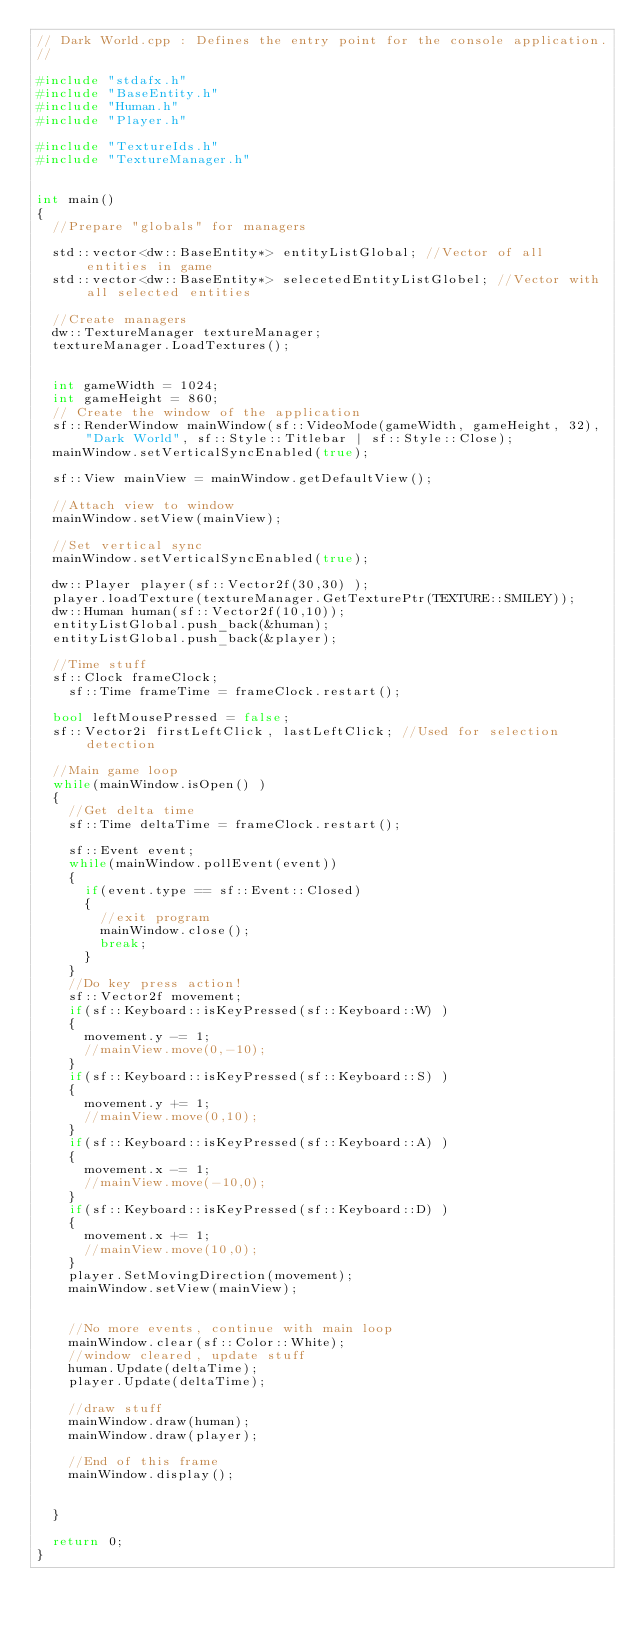Convert code to text. <code><loc_0><loc_0><loc_500><loc_500><_C++_>// Dark World.cpp : Defines the entry point for the console application.
//

#include "stdafx.h"
#include "BaseEntity.h"
#include "Human.h"
#include "Player.h"

#include "TextureIds.h"
#include "TextureManager.h"


int main()
{
  //Prepare "globals" for managers

  std::vector<dw::BaseEntity*> entityListGlobal; //Vector of all entities in game
  std::vector<dw::BaseEntity*> selecetedEntityListGlobel; //Vector with all selected entities

  //Create managers
  dw::TextureManager textureManager;
  textureManager.LoadTextures();


  int gameWidth = 1024;
  int gameHeight = 860;
  // Create the window of the application
  sf::RenderWindow mainWindow(sf::VideoMode(gameWidth, gameHeight, 32), "Dark World", sf::Style::Titlebar | sf::Style::Close);
  mainWindow.setVerticalSyncEnabled(true);

  sf::View mainView = mainWindow.getDefaultView();

  //Attach view to window
  mainWindow.setView(mainView);

  //Set vertical sync
  mainWindow.setVerticalSyncEnabled(true);

  dw::Player player(sf::Vector2f(30,30) );
  player.loadTexture(textureManager.GetTexturePtr(TEXTURE::SMILEY));
  dw::Human human(sf::Vector2f(10,10));
  entityListGlobal.push_back(&human);
  entityListGlobal.push_back(&player);

  //Time stuff
  sf::Clock frameClock;
	sf::Time frameTime = frameClock.restart();

  bool leftMousePressed = false;
  sf::Vector2i firstLeftClick, lastLeftClick; //Used for selection detection

  //Main game loop
  while(mainWindow.isOpen() )
  {
    //Get delta time
    sf::Time deltaTime = frameClock.restart();

    sf::Event event;
    while(mainWindow.pollEvent(event))
    {
      if(event.type == sf::Event::Closed)
      {
        //exit program
        mainWindow.close();
        break;
      }
    }
    //Do key press action!
    sf::Vector2f movement;
    if(sf::Keyboard::isKeyPressed(sf::Keyboard::W) )
    {
      movement.y -= 1;
      //mainView.move(0,-10);
    }
    if(sf::Keyboard::isKeyPressed(sf::Keyboard::S) )
    {
      movement.y += 1;
      //mainView.move(0,10);
    }
    if(sf::Keyboard::isKeyPressed(sf::Keyboard::A) )
    {
      movement.x -= 1;
      //mainView.move(-10,0);
    }
    if(sf::Keyboard::isKeyPressed(sf::Keyboard::D) )
    {
      movement.x += 1;
      //mainView.move(10,0);
    }
    player.SetMovingDirection(movement);
    mainWindow.setView(mainView);


    //No more events, continue with main loop
    mainWindow.clear(sf::Color::White);
    //window cleared, update stuff
    human.Update(deltaTime);
    player.Update(deltaTime);

    //draw stuff
    mainWindow.draw(human);
    mainWindow.draw(player);

    //End of this frame
    mainWindow.display();


  }

  return 0;
}

</code> 